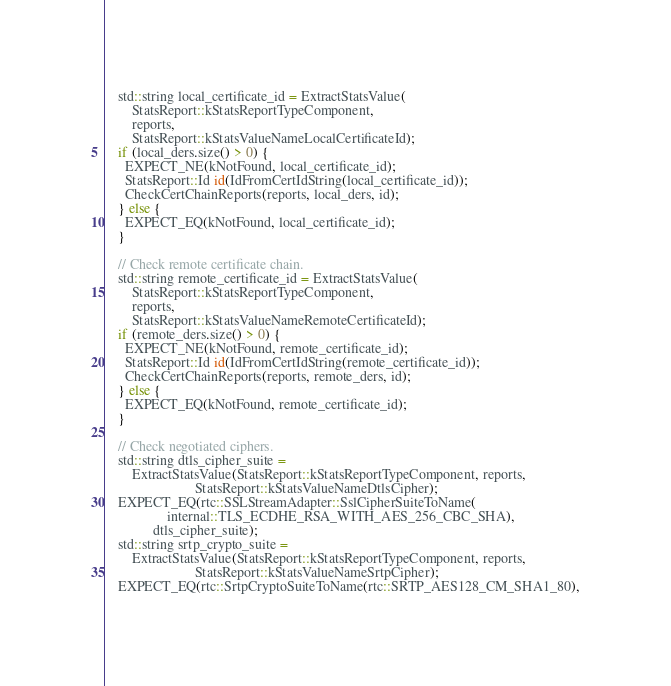Convert code to text. <code><loc_0><loc_0><loc_500><loc_500><_C++_>    std::string local_certificate_id = ExtractStatsValue(
        StatsReport::kStatsReportTypeComponent,
        reports,
        StatsReport::kStatsValueNameLocalCertificateId);
    if (local_ders.size() > 0) {
      EXPECT_NE(kNotFound, local_certificate_id);
      StatsReport::Id id(IdFromCertIdString(local_certificate_id));
      CheckCertChainReports(reports, local_ders, id);
    } else {
      EXPECT_EQ(kNotFound, local_certificate_id);
    }

    // Check remote certificate chain.
    std::string remote_certificate_id = ExtractStatsValue(
        StatsReport::kStatsReportTypeComponent,
        reports,
        StatsReport::kStatsValueNameRemoteCertificateId);
    if (remote_ders.size() > 0) {
      EXPECT_NE(kNotFound, remote_certificate_id);
      StatsReport::Id id(IdFromCertIdString(remote_certificate_id));
      CheckCertChainReports(reports, remote_ders, id);
    } else {
      EXPECT_EQ(kNotFound, remote_certificate_id);
    }

    // Check negotiated ciphers.
    std::string dtls_cipher_suite =
        ExtractStatsValue(StatsReport::kStatsReportTypeComponent, reports,
                          StatsReport::kStatsValueNameDtlsCipher);
    EXPECT_EQ(rtc::SSLStreamAdapter::SslCipherSuiteToName(
                  internal::TLS_ECDHE_RSA_WITH_AES_256_CBC_SHA),
              dtls_cipher_suite);
    std::string srtp_crypto_suite =
        ExtractStatsValue(StatsReport::kStatsReportTypeComponent, reports,
                          StatsReport::kStatsValueNameSrtpCipher);
    EXPECT_EQ(rtc::SrtpCryptoSuiteToName(rtc::SRTP_AES128_CM_SHA1_80),</code> 